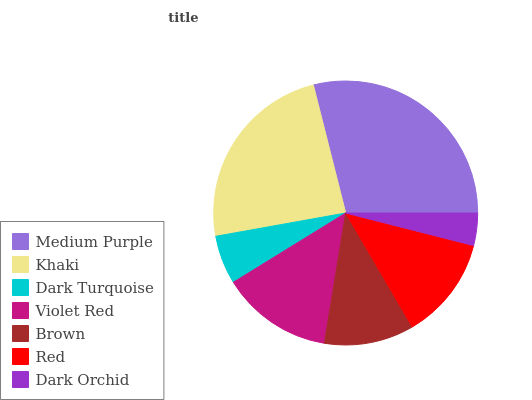Is Dark Orchid the minimum?
Answer yes or no. Yes. Is Medium Purple the maximum?
Answer yes or no. Yes. Is Khaki the minimum?
Answer yes or no. No. Is Khaki the maximum?
Answer yes or no. No. Is Medium Purple greater than Khaki?
Answer yes or no. Yes. Is Khaki less than Medium Purple?
Answer yes or no. Yes. Is Khaki greater than Medium Purple?
Answer yes or no. No. Is Medium Purple less than Khaki?
Answer yes or no. No. Is Red the high median?
Answer yes or no. Yes. Is Red the low median?
Answer yes or no. Yes. Is Violet Red the high median?
Answer yes or no. No. Is Brown the low median?
Answer yes or no. No. 